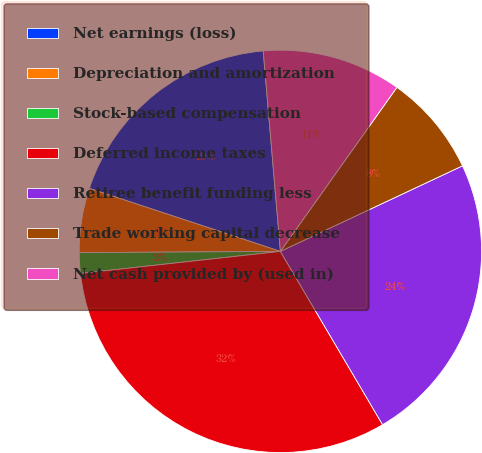Convert chart. <chart><loc_0><loc_0><loc_500><loc_500><pie_chart><fcel>Net earnings (loss)<fcel>Depreciation and amortization<fcel>Stock-based compensation<fcel>Deferred income taxes<fcel>Retiree benefit funding less<fcel>Trade working capital decrease<fcel>Net cash provided by (used in)<nl><fcel>18.57%<fcel>5.17%<fcel>1.65%<fcel>31.73%<fcel>23.51%<fcel>8.18%<fcel>11.19%<nl></chart> 